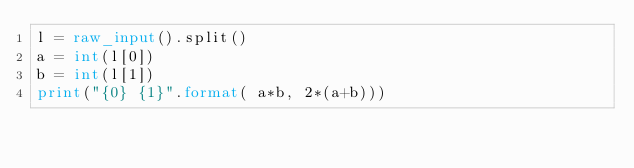<code> <loc_0><loc_0><loc_500><loc_500><_Python_>l = raw_input().split()
a = int(l[0])
b = int(l[1])
print("{0} {1}".format( a*b, 2*(a+b)))</code> 